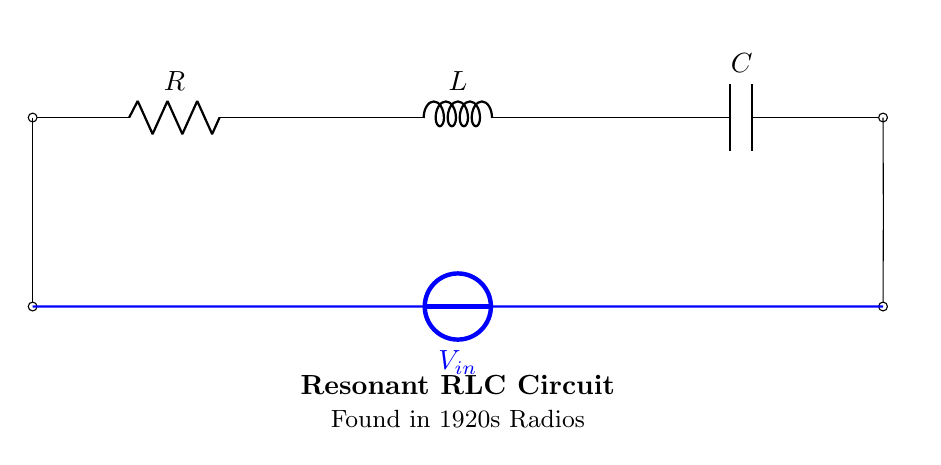What type of circuit is depicted? The diagram illustrates a resonant RLC circuit, characterized by the presence of a resistor, inductor, and capacitor in series.
Answer: resonant RLC circuit What was the primary application of this circuit? This circuit was commonly used in 1920s radios to select frequencies, revealing its importance in the advancement of radio technology during that period.
Answer: radios What components are present in the circuit? The circuit includes a resistor, an inductor, and a capacitor, which collectively define its resonant characteristics.
Answer: resistor, inductor, capacitor What decade is likely represented by this circuit? The note on the diagram indicates that the circuit was used in the 1920s, which is a significant era for radio technology.
Answer: 1920s What does the input voltage symbol signify? The voltage symbol indicates the input voltage supplied to the circuit, which is essential for its operation and functionality.
Answer: input voltage How does resonance occur in this RLC circuit? Resonance occurs when the inductive reactance equals the capacitive reactance at a specific frequency, maximizing current through the circuit.
Answer: when inductive reactance equals capacitive reactance What major technological era is associated with the use of this circuit? The diagram highlights the Golden Age of Radio, emphasizing the significance of this circuit in that transformative time for communication.
Answer: Golden Age of Radio 